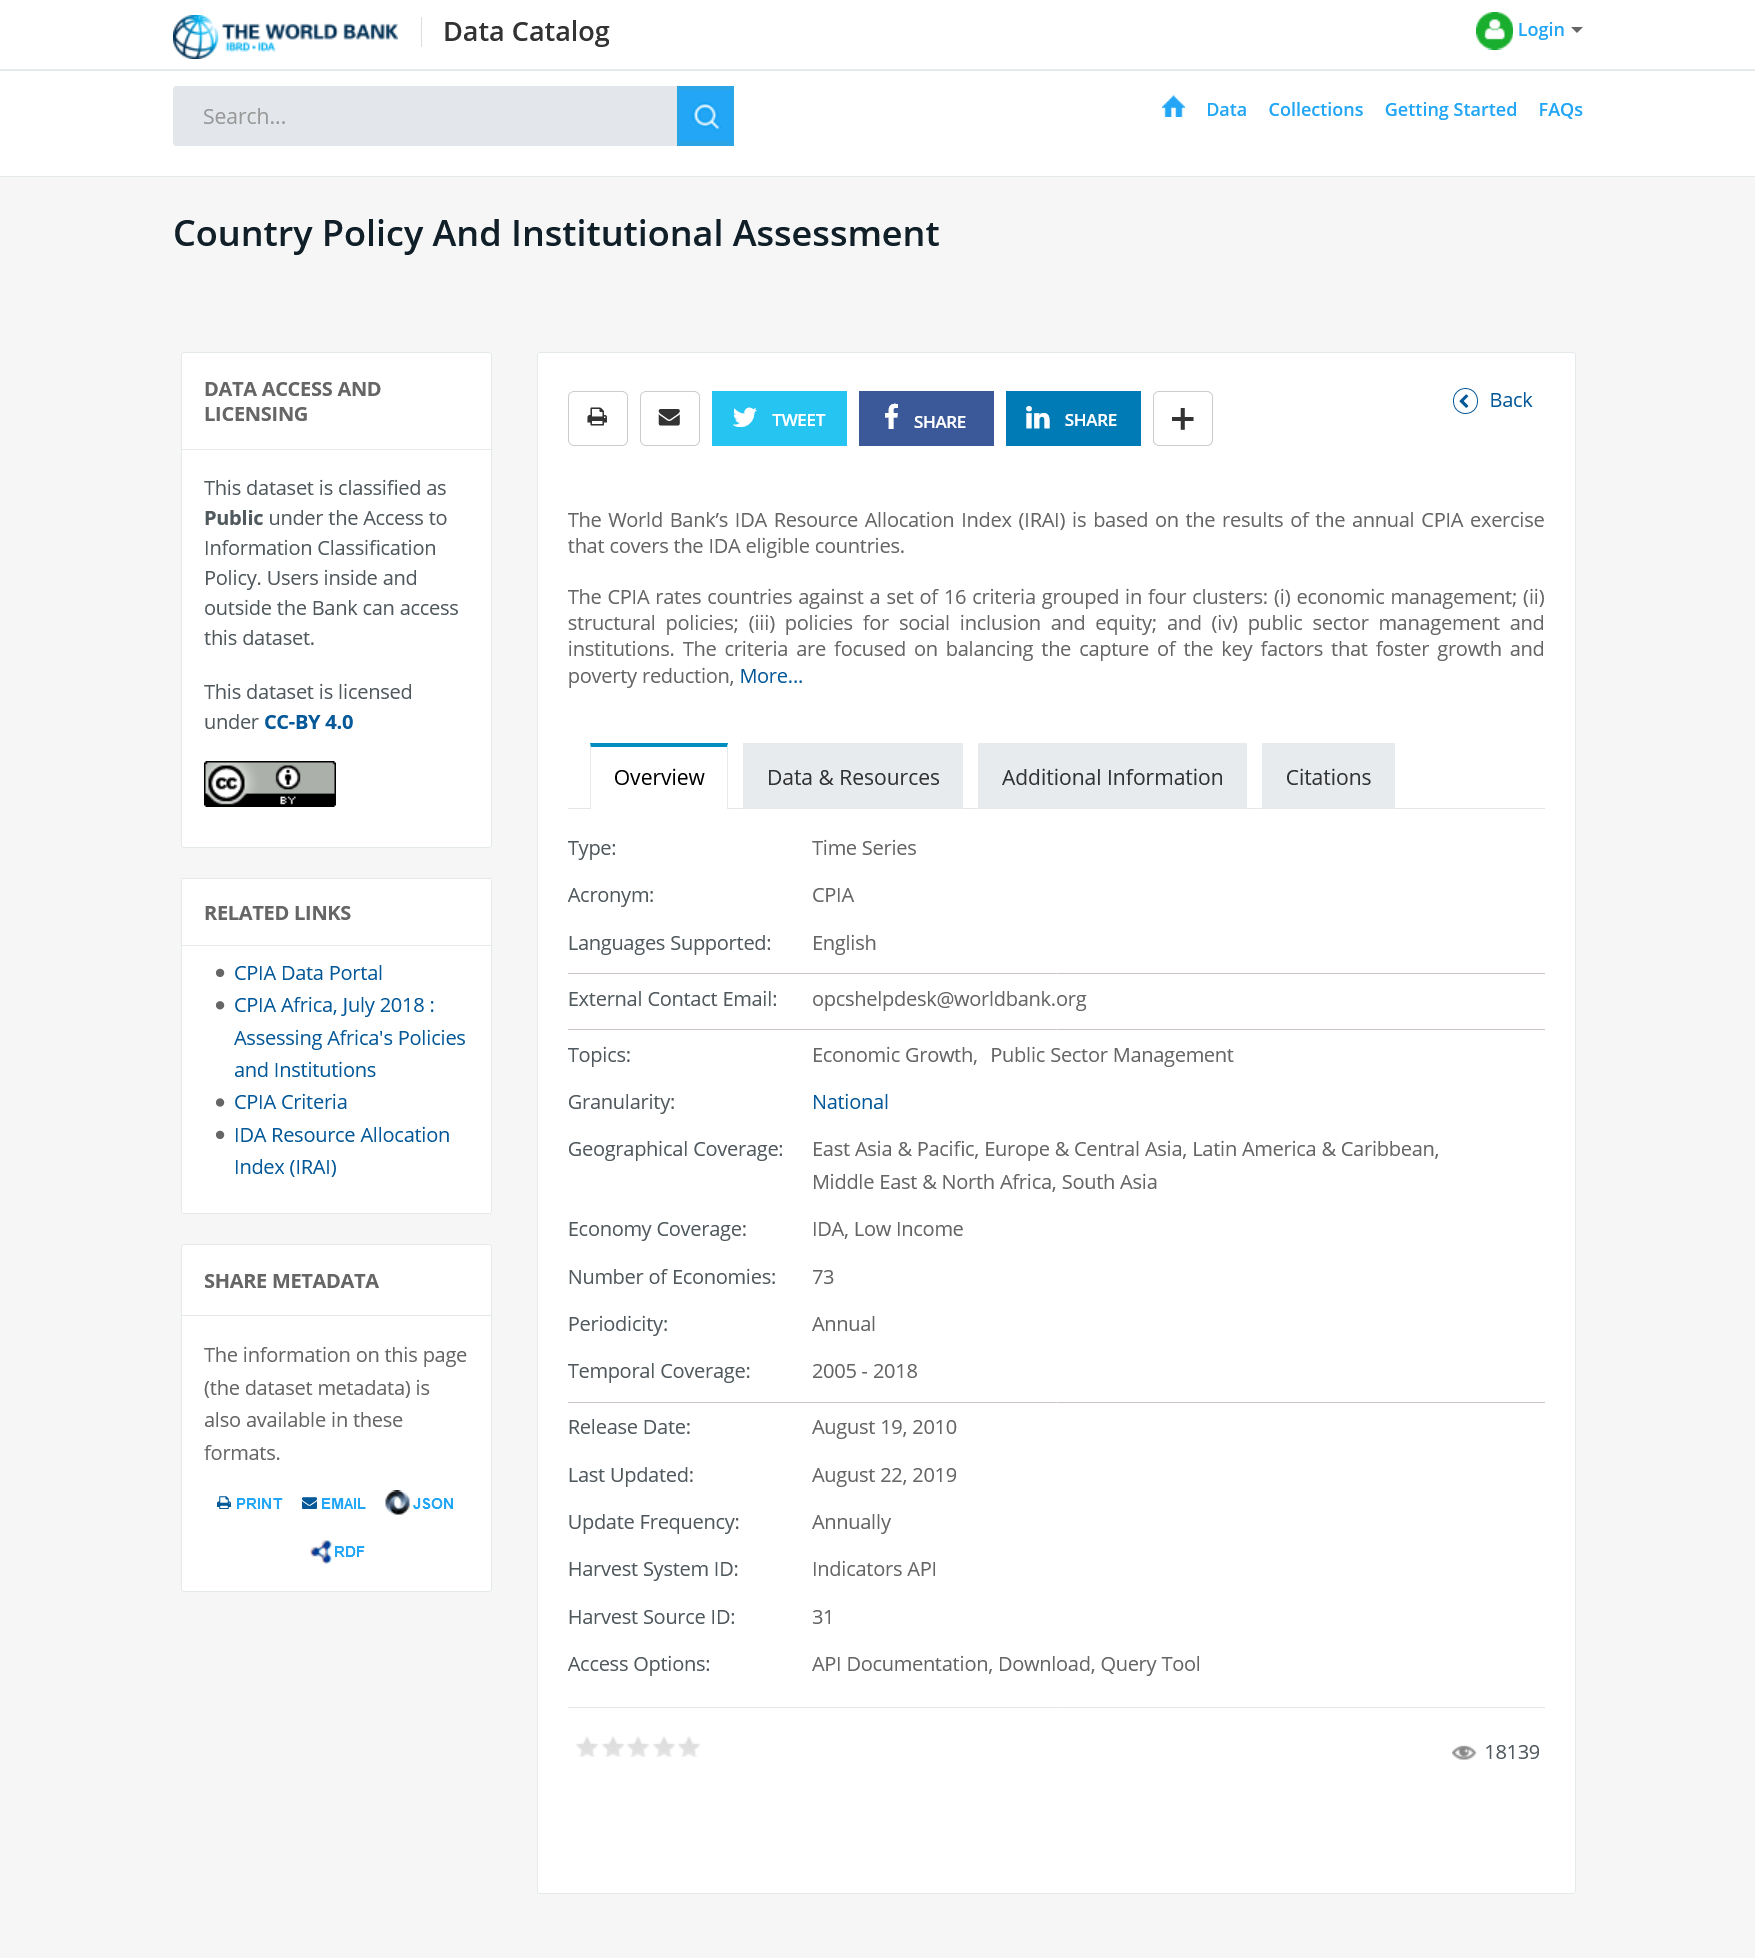Outline some significant characteristics in this image. The IRAI is based on the results of the annual CPIA exercise, which provides a comprehensive assessment of the implementation of the Voluntary Guidelines on the Responsible Governance of Tenure of Land, Fisheries and Forests in the Context of National Food Security. The dataset is classified as public. Social media can be utilized as a platform to share content. 